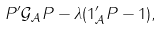<formula> <loc_0><loc_0><loc_500><loc_500>P ^ { \prime } { \mathcal { G } } _ { \mathcal { A } } P - \lambda ( { 1 } _ { \mathcal { A } } ^ { \prime } P - 1 ) ,</formula> 